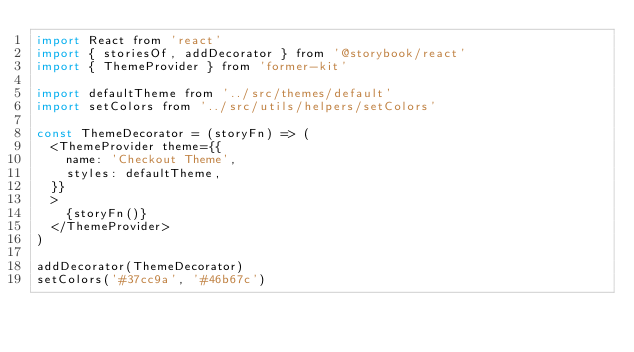Convert code to text. <code><loc_0><loc_0><loc_500><loc_500><_JavaScript_>import React from 'react'
import { storiesOf, addDecorator } from '@storybook/react'
import { ThemeProvider } from 'former-kit'

import defaultTheme from '../src/themes/default'
import setColors from '../src/utils/helpers/setColors'

const ThemeDecorator = (storyFn) => (
  <ThemeProvider theme={{
    name: 'Checkout Theme',
    styles: defaultTheme,
  }}
  >
    {storyFn()}
  </ThemeProvider>
)

addDecorator(ThemeDecorator)
setColors('#37cc9a', '#46b67c')
</code> 